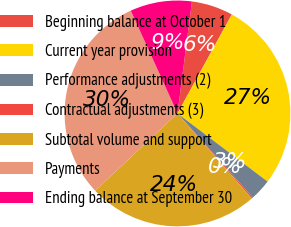Convert chart to OTSL. <chart><loc_0><loc_0><loc_500><loc_500><pie_chart><fcel>Beginning balance at October 1<fcel>Current year provision<fcel>Performance adjustments (2)<fcel>Contractual adjustments (3)<fcel>Subtotal volume and support<fcel>Payments<fcel>Ending balance at September 30<nl><fcel>5.95%<fcel>27.32%<fcel>3.07%<fcel>0.19%<fcel>24.44%<fcel>30.2%<fcel>8.83%<nl></chart> 